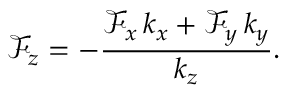<formula> <loc_0><loc_0><loc_500><loc_500>\mathcal { F } _ { z } = - \frac { \mathcal { F } _ { x } \, k _ { x } + \mathcal { F } _ { y } \, k _ { y } } { k _ { z } } .</formula> 